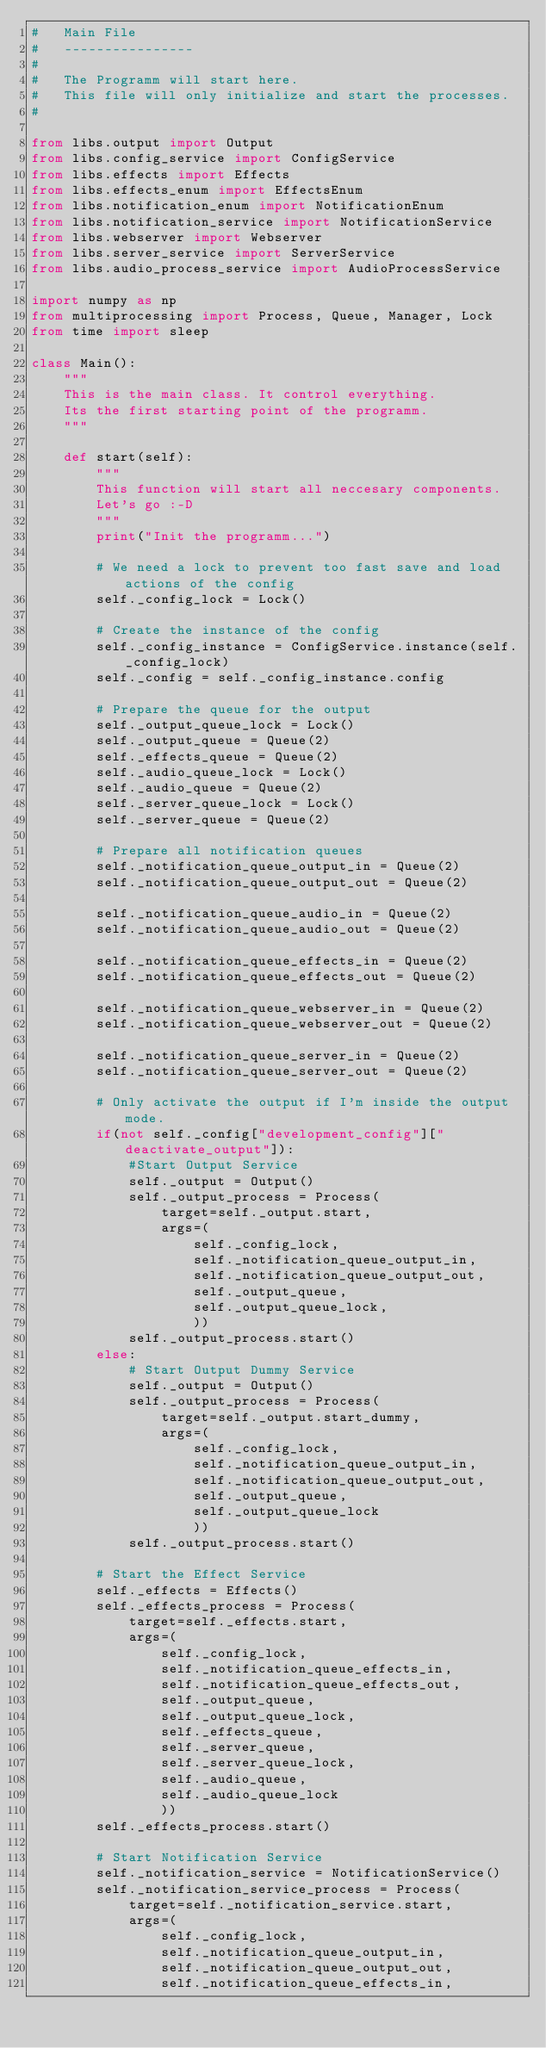Convert code to text. <code><loc_0><loc_0><loc_500><loc_500><_Python_>#   Main File
#   ----------------
# 
#   The Programm will start here.
#   This file will only initialize and start the processes.
#

from libs.output import Output
from libs.config_service import ConfigService
from libs.effects import Effects
from libs.effects_enum import EffectsEnum
from libs.notification_enum import NotificationEnum
from libs.notification_service import NotificationService
from libs.webserver import Webserver
from libs.server_service import ServerService
from libs.audio_process_service import AudioProcessService

import numpy as np
from multiprocessing import Process, Queue, Manager, Lock
from time import sleep

class Main():
    """
    This is the main class. It control everything.
    Its the first starting point of the programm.
    """

    def start(self):
        """
        This function will start all neccesary components.
        Let's go :-D
        """
        print("Init the programm...")

        # We need a lock to prevent too fast save and load actions of the config
        self._config_lock = Lock()

        # Create the instance of the config
        self._config_instance = ConfigService.instance(self._config_lock)
        self._config = self._config_instance.config        

        # Prepare the queue for the output
        self._output_queue_lock = Lock()
        self._output_queue = Queue(2)
        self._effects_queue = Queue(2)
        self._audio_queue_lock = Lock()
        self._audio_queue = Queue(2)
        self._server_queue_lock = Lock()
        self._server_queue = Queue(2)

        # Prepare all notification queues
        self._notification_queue_output_in = Queue(2)
        self._notification_queue_output_out = Queue(2)

        self._notification_queue_audio_in = Queue(2)
        self._notification_queue_audio_out = Queue(2)

        self._notification_queue_effects_in = Queue(2)
        self._notification_queue_effects_out = Queue(2)

        self._notification_queue_webserver_in = Queue(2)
        self._notification_queue_webserver_out = Queue(2)

        self._notification_queue_server_in = Queue(2)
        self._notification_queue_server_out = Queue(2)

        # Only activate the output if I'm inside the output mode.
        if(not self._config["development_config"]["deactivate_output"]):
            #Start Output Service
            self._output = Output()
            self._output_process = Process(
                target=self._output.start, 
                args=(
                    self._config_lock, 
                    self._notification_queue_output_in, 
                    self._notification_queue_output_out, 
                    self._output_queue, 
                    self._output_queue_lock, 
                    ))
            self._output_process.start()
        else:
            # Start Output Dummy Service
            self._output = Output()
            self._output_process = Process(
                target=self._output.start_dummy, 
                args=(
                    self._config_lock, 
                    self._notification_queue_output_in, 
                    self._notification_queue_output_out, 
                    self._output_queue, 
                    self._output_queue_lock
                    ))
            self._output_process.start()

        # Start the Effect Service
        self._effects = Effects()
        self._effects_process = Process(
            target=self._effects.start, 
            args=(
                self._config_lock, 
                self._notification_queue_effects_in, 
                self._notification_queue_effects_out, 
                self._output_queue, 
                self._output_queue_lock,
                self._effects_queue,
                self._server_queue,
                self._server_queue_lock,
                self._audio_queue,
                self._audio_queue_lock
                ))
        self._effects_process.start()

        # Start Notification Service
        self._notification_service = NotificationService()
        self._notification_service_process = Process(
            target=self._notification_service.start, 
            args=(
                self._config_lock, 
                self._notification_queue_output_in, 
                self._notification_queue_output_out, 
                self._notification_queue_effects_in, </code> 